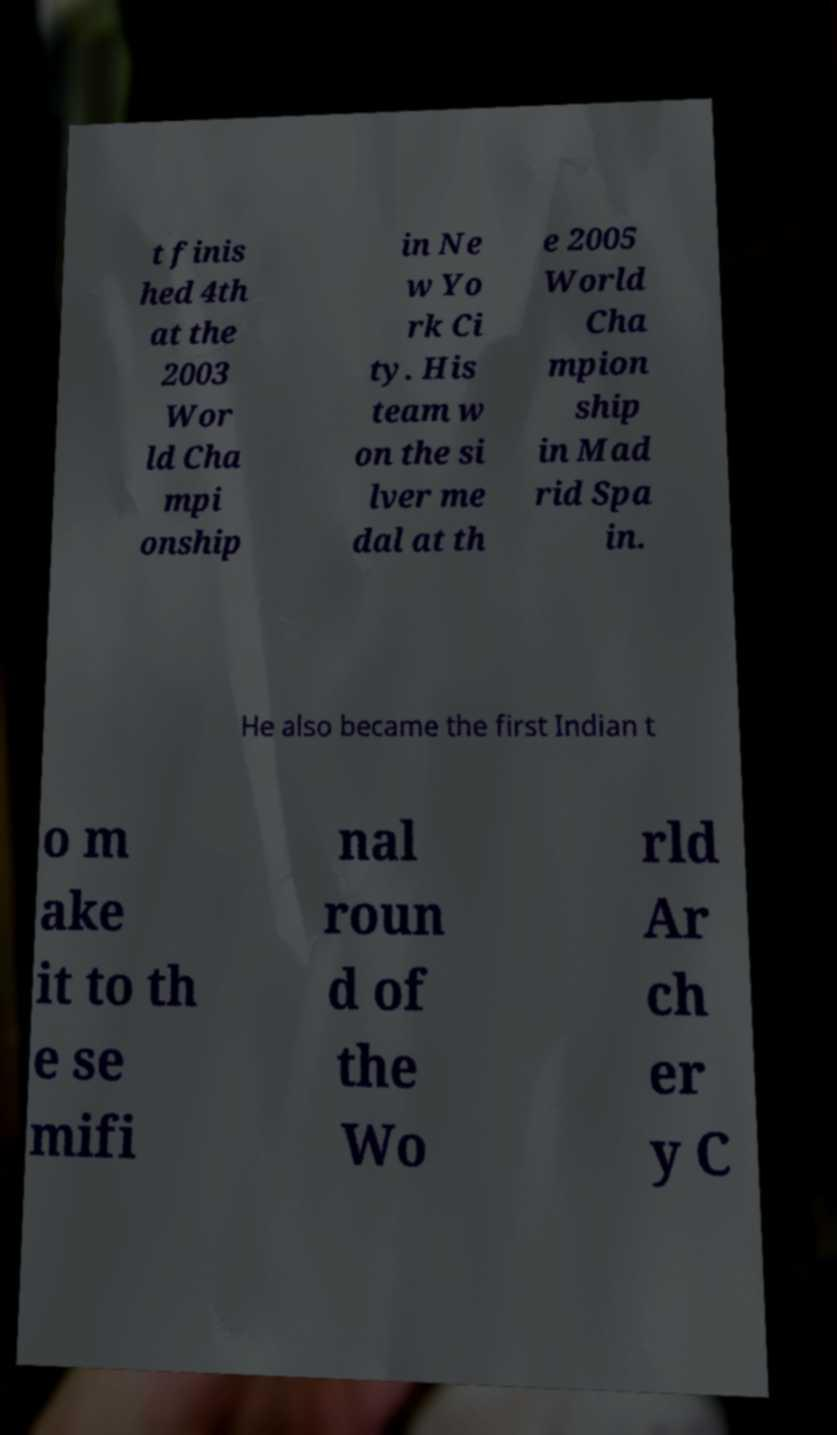Could you assist in decoding the text presented in this image and type it out clearly? t finis hed 4th at the 2003 Wor ld Cha mpi onship in Ne w Yo rk Ci ty. His team w on the si lver me dal at th e 2005 World Cha mpion ship in Mad rid Spa in. He also became the first Indian t o m ake it to th e se mifi nal roun d of the Wo rld Ar ch er y C 